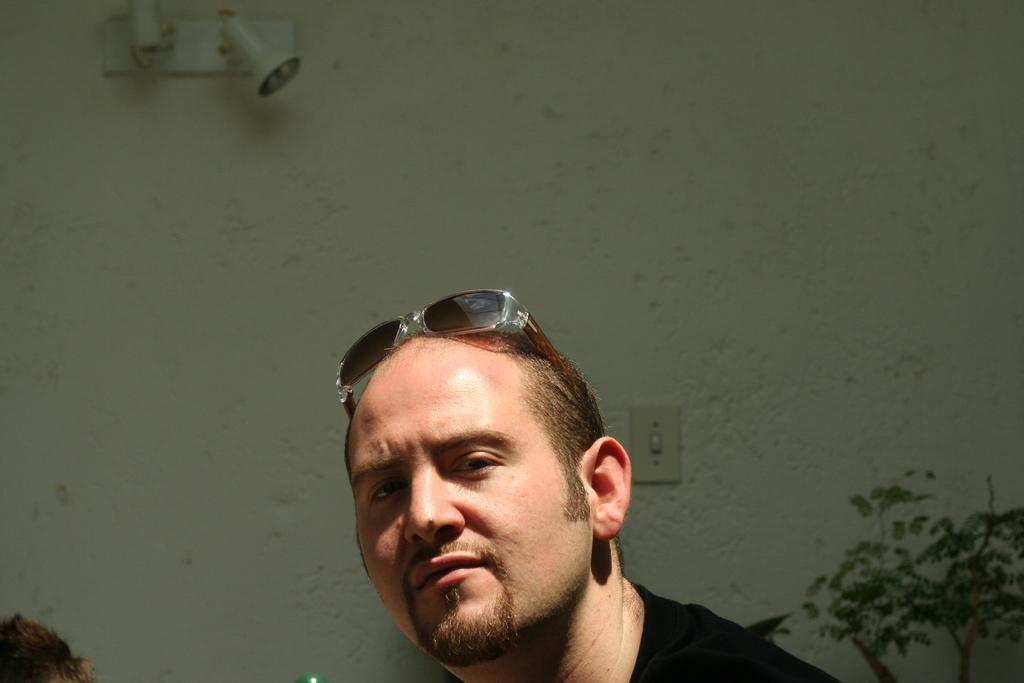Who is present in the image? There is a man in the image. What accessory is the man wearing? The man is wearing glasses. What can be seen in the background of the image? There is a plant, a wall, and light visible in the background of the image. What event is the man attending in the image? There is no indication of an event in the image; it simply shows a man wearing glasses with a background containing a plant, a wall, and light. 